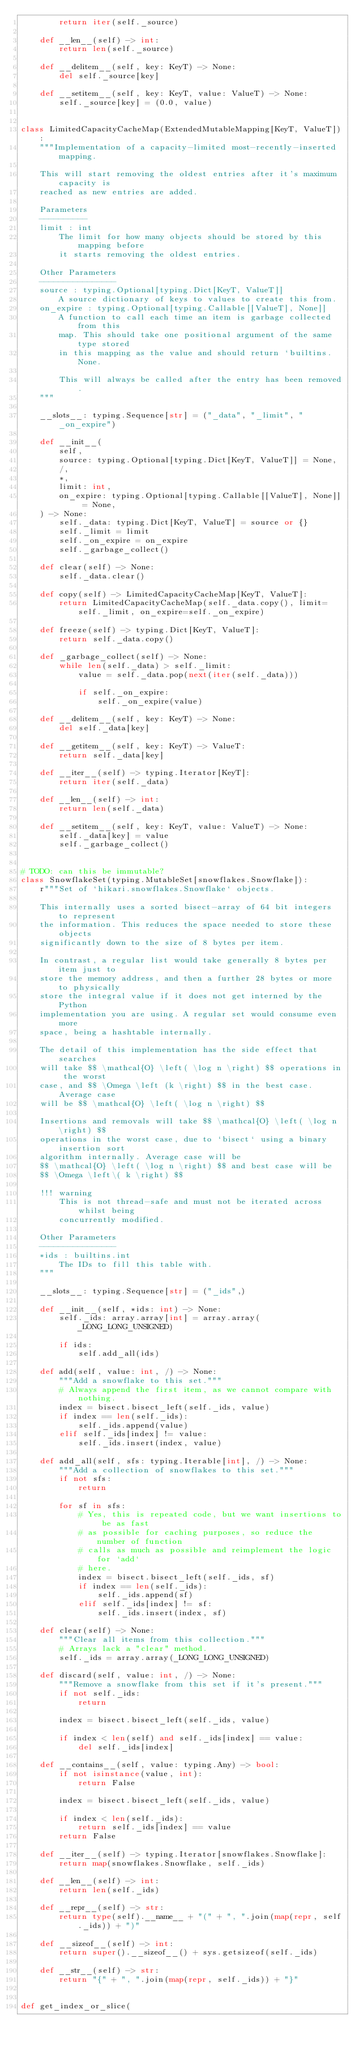Convert code to text. <code><loc_0><loc_0><loc_500><loc_500><_Python_>        return iter(self._source)

    def __len__(self) -> int:
        return len(self._source)

    def __delitem__(self, key: KeyT) -> None:
        del self._source[key]

    def __setitem__(self, key: KeyT, value: ValueT) -> None:
        self._source[key] = (0.0, value)


class LimitedCapacityCacheMap(ExtendedMutableMapping[KeyT, ValueT]):
    """Implementation of a capacity-limited most-recently-inserted mapping.

    This will start removing the oldest entries after it's maximum capacity is
    reached as new entries are added.

    Parameters
    ----------
    limit : int
        The limit for how many objects should be stored by this mapping before
        it starts removing the oldest entries.

    Other Parameters
    ----------------
    source : typing.Optional[typing.Dict[KeyT, ValueT]]
        A source dictionary of keys to values to create this from.
    on_expire : typing.Optional[typing.Callable[[ValueT], None]]
        A function to call each time an item is garbage collected from this
        map. This should take one positional argument of the same type stored
        in this mapping as the value and should return `builtins.None.

        This will always be called after the entry has been removed.
    """

    __slots__: typing.Sequence[str] = ("_data", "_limit", "_on_expire")

    def __init__(
        self,
        source: typing.Optional[typing.Dict[KeyT, ValueT]] = None,
        /,
        *,
        limit: int,
        on_expire: typing.Optional[typing.Callable[[ValueT], None]] = None,
    ) -> None:
        self._data: typing.Dict[KeyT, ValueT] = source or {}
        self._limit = limit
        self._on_expire = on_expire
        self._garbage_collect()

    def clear(self) -> None:
        self._data.clear()

    def copy(self) -> LimitedCapacityCacheMap[KeyT, ValueT]:
        return LimitedCapacityCacheMap(self._data.copy(), limit=self._limit, on_expire=self._on_expire)

    def freeze(self) -> typing.Dict[KeyT, ValueT]:
        return self._data.copy()

    def _garbage_collect(self) -> None:
        while len(self._data) > self._limit:
            value = self._data.pop(next(iter(self._data)))

            if self._on_expire:
                self._on_expire(value)

    def __delitem__(self, key: KeyT) -> None:
        del self._data[key]

    def __getitem__(self, key: KeyT) -> ValueT:
        return self._data[key]

    def __iter__(self) -> typing.Iterator[KeyT]:
        return iter(self._data)

    def __len__(self) -> int:
        return len(self._data)

    def __setitem__(self, key: KeyT, value: ValueT) -> None:
        self._data[key] = value
        self._garbage_collect()


# TODO: can this be immutable?
class SnowflakeSet(typing.MutableSet[snowflakes.Snowflake]):
    r"""Set of `hikari.snowflakes.Snowflake` objects.

    This internally uses a sorted bisect-array of 64 bit integers to represent
    the information. This reduces the space needed to store these objects
    significantly down to the size of 8 bytes per item.

    In contrast, a regular list would take generally 8 bytes per item just to
    store the memory address, and then a further 28 bytes or more to physically
    store the integral value if it does not get interned by the Python
    implementation you are using. A regular set would consume even more
    space, being a hashtable internally.

    The detail of this implementation has the side effect that searches
    will take $$ \mathcal{O} \left( \log n \right) $$ operations in the worst
    case, and $$ \Omega \left (k \right) $$ in the best case. Average case
    will be $$ \mathcal{O} \left( \log n \right) $$

    Insertions and removals will take $$ \mathcal{O} \left( \log n \right) $$
    operations in the worst case, due to `bisect` using a binary insertion sort
    algorithm internally. Average case will be
    $$ \mathcal{O} \left( \log n \right) $$ and best case will be
    $$ \Omega \left\( k \right) $$

    !!! warning
        This is not thread-safe and must not be iterated across whilst being
        concurrently modified.

    Other Parameters
    ----------------
    *ids : builtins.int
        The IDs to fill this table with.
    """

    __slots__: typing.Sequence[str] = ("_ids",)

    def __init__(self, *ids: int) -> None:
        self._ids: array.array[int] = array.array(_LONG_LONG_UNSIGNED)

        if ids:
            self.add_all(ids)

    def add(self, value: int, /) -> None:
        """Add a snowflake to this set."""
        # Always append the first item, as we cannot compare with nothing.
        index = bisect.bisect_left(self._ids, value)
        if index == len(self._ids):
            self._ids.append(value)
        elif self._ids[index] != value:
            self._ids.insert(index, value)

    def add_all(self, sfs: typing.Iterable[int], /) -> None:
        """Add a collection of snowflakes to this set."""
        if not sfs:
            return

        for sf in sfs:
            # Yes, this is repeated code, but we want insertions to be as fast
            # as possible for caching purposes, so reduce the number of function
            # calls as much as possible and reimplement the logic for `add`
            # here.
            index = bisect.bisect_left(self._ids, sf)
            if index == len(self._ids):
                self._ids.append(sf)
            elif self._ids[index] != sf:
                self._ids.insert(index, sf)

    def clear(self) -> None:
        """Clear all items from this collection."""
        # Arrays lack a "clear" method.
        self._ids = array.array(_LONG_LONG_UNSIGNED)

    def discard(self, value: int, /) -> None:
        """Remove a snowflake from this set if it's present."""
        if not self._ids:
            return

        index = bisect.bisect_left(self._ids, value)

        if index < len(self) and self._ids[index] == value:
            del self._ids[index]

    def __contains__(self, value: typing.Any) -> bool:
        if not isinstance(value, int):
            return False

        index = bisect.bisect_left(self._ids, value)

        if index < len(self._ids):
            return self._ids[index] == value
        return False

    def __iter__(self) -> typing.Iterator[snowflakes.Snowflake]:
        return map(snowflakes.Snowflake, self._ids)

    def __len__(self) -> int:
        return len(self._ids)

    def __repr__(self) -> str:
        return type(self).__name__ + "(" + ", ".join(map(repr, self._ids)) + ")"

    def __sizeof__(self) -> int:
        return super().__sizeof__() + sys.getsizeof(self._ids)

    def __str__(self) -> str:
        return "{" + ", ".join(map(repr, self._ids)) + "}"


def get_index_or_slice(</code> 